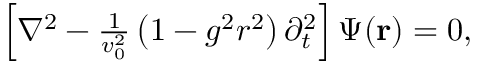Convert formula to latex. <formula><loc_0><loc_0><loc_500><loc_500>\begin{array} { r } { \left [ \nabla ^ { 2 } - \frac { 1 } { v _ { 0 } ^ { 2 } } \left ( 1 - g ^ { 2 } r ^ { 2 } \right ) \partial _ { t } ^ { 2 } \right ] \Psi ( { r } ) = 0 , } \end{array}</formula> 